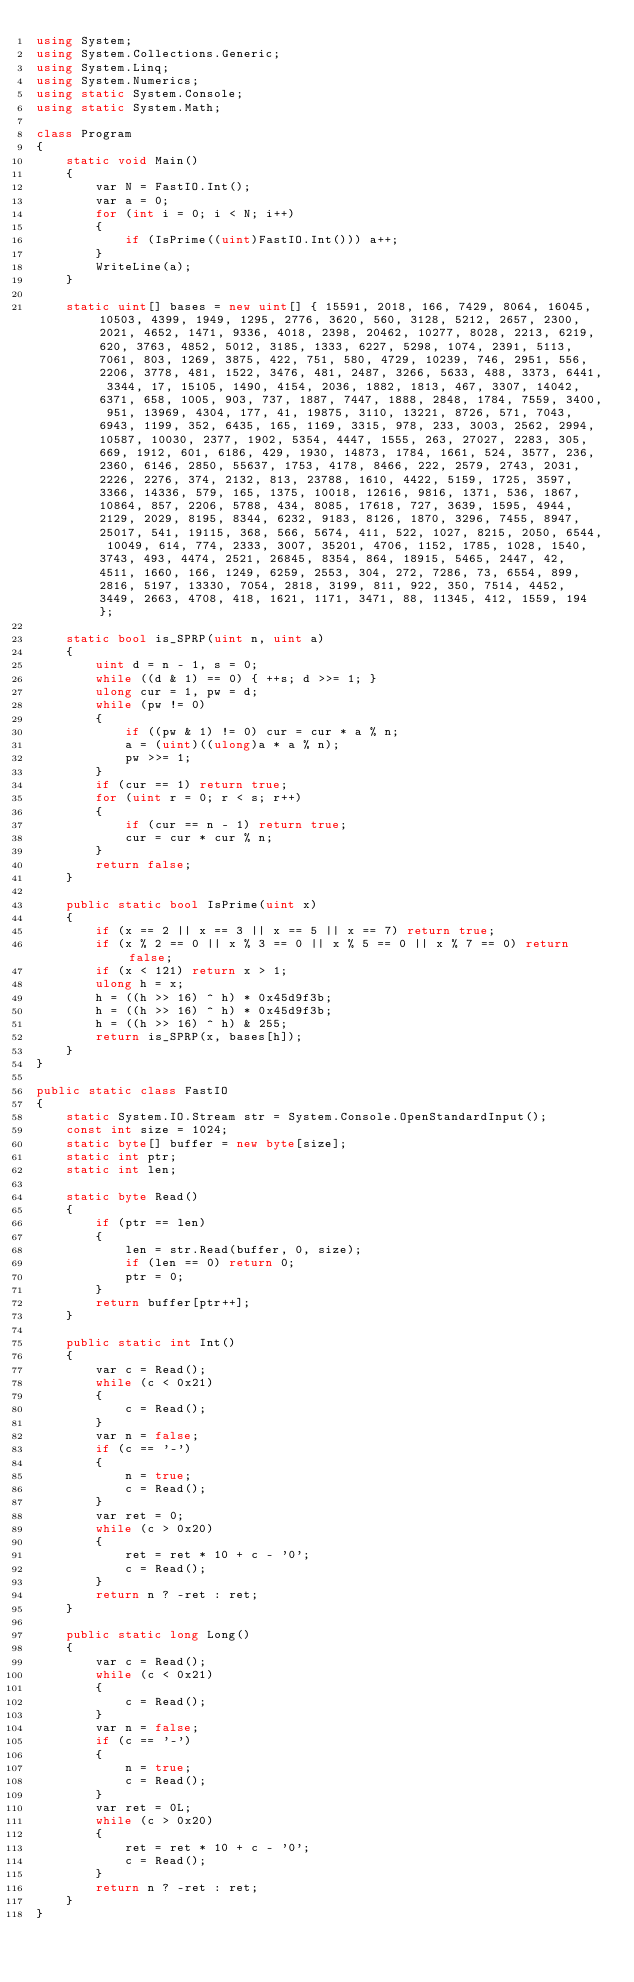<code> <loc_0><loc_0><loc_500><loc_500><_C#_>using System;
using System.Collections.Generic;
using System.Linq;
using System.Numerics;
using static System.Console;
using static System.Math;

class Program
{
    static void Main()
    {
        var N = FastIO.Int();
        var a = 0;
        for (int i = 0; i < N; i++)
        {
            if (IsPrime((uint)FastIO.Int())) a++;
        }
        WriteLine(a);
    }
    
    static uint[] bases = new uint[] { 15591, 2018, 166, 7429, 8064, 16045, 10503, 4399, 1949, 1295, 2776, 3620, 560, 3128, 5212, 2657, 2300, 2021, 4652, 1471, 9336, 4018, 2398, 20462, 10277, 8028, 2213, 6219, 620, 3763, 4852, 5012, 3185, 1333, 6227, 5298, 1074, 2391, 5113, 7061, 803, 1269, 3875, 422, 751, 580, 4729, 10239, 746, 2951, 556, 2206, 3778, 481, 1522, 3476, 481, 2487, 3266, 5633, 488, 3373, 6441, 3344, 17, 15105, 1490, 4154, 2036, 1882, 1813, 467, 3307, 14042, 6371, 658, 1005, 903, 737, 1887, 7447, 1888, 2848, 1784, 7559, 3400, 951, 13969, 4304, 177, 41, 19875, 3110, 13221, 8726, 571, 7043, 6943, 1199, 352, 6435, 165, 1169, 3315, 978, 233, 3003, 2562, 2994, 10587, 10030, 2377, 1902, 5354, 4447, 1555, 263, 27027, 2283, 305, 669, 1912, 601, 6186, 429, 1930, 14873, 1784, 1661, 524, 3577, 236, 2360, 6146, 2850, 55637, 1753, 4178, 8466, 222, 2579, 2743, 2031, 2226, 2276, 374, 2132, 813, 23788, 1610, 4422, 5159, 1725, 3597, 3366, 14336, 579, 165, 1375, 10018, 12616, 9816, 1371, 536, 1867, 10864, 857, 2206, 5788, 434, 8085, 17618, 727, 3639, 1595, 4944, 2129, 2029, 8195, 8344, 6232, 9183, 8126, 1870, 3296, 7455, 8947, 25017, 541, 19115, 368, 566, 5674, 411, 522, 1027, 8215, 2050, 6544, 10049, 614, 774, 2333, 3007, 35201, 4706, 1152, 1785, 1028, 1540, 3743, 493, 4474, 2521, 26845, 8354, 864, 18915, 5465, 2447, 42, 4511, 1660, 166, 1249, 6259, 2553, 304, 272, 7286, 73, 6554, 899, 2816, 5197, 13330, 7054, 2818, 3199, 811, 922, 350, 7514, 4452, 3449, 2663, 4708, 418, 1621, 1171, 3471, 88, 11345, 412, 1559, 194 };

    static bool is_SPRP(uint n, uint a)
    {
        uint d = n - 1, s = 0;
        while ((d & 1) == 0) { ++s; d >>= 1; }
        ulong cur = 1, pw = d;
        while (pw != 0)
        {
            if ((pw & 1) != 0) cur = cur * a % n;
            a = (uint)((ulong)a * a % n);
            pw >>= 1;
        }
        if (cur == 1) return true;
        for (uint r = 0; r < s; r++)
        {
            if (cur == n - 1) return true;
            cur = cur * cur % n;
        }
        return false;
    }

    public static bool IsPrime(uint x)
    {
        if (x == 2 || x == 3 || x == 5 || x == 7) return true;
        if (x % 2 == 0 || x % 3 == 0 || x % 5 == 0 || x % 7 == 0) return false;
        if (x < 121) return x > 1;
        ulong h = x;
        h = ((h >> 16) ^ h) * 0x45d9f3b;
        h = ((h >> 16) ^ h) * 0x45d9f3b;
        h = ((h >> 16) ^ h) & 255;
        return is_SPRP(x, bases[h]);
    }
}

public static class FastIO
{
    static System.IO.Stream str = System.Console.OpenStandardInput();
    const int size = 1024;
    static byte[] buffer = new byte[size];
    static int ptr;
    static int len;

    static byte Read()
    {
        if (ptr == len)
        {
            len = str.Read(buffer, 0, size);
            if (len == 0) return 0;
            ptr = 0;
        }
        return buffer[ptr++];
    }

    public static int Int()
    {
        var c = Read();
        while (c < 0x21)
        {
            c = Read();
        }
        var n = false;
        if (c == '-')
        {
            n = true;
            c = Read();
        }
        var ret = 0;
        while (c > 0x20)
        {
            ret = ret * 10 + c - '0';
            c = Read();
        }
        return n ? -ret : ret;
    }

    public static long Long()
    {
        var c = Read();
        while (c < 0x21)
        {
            c = Read();
        }
        var n = false;
        if (c == '-')
        {
            n = true;
            c = Read();
        }
        var ret = 0L;
        while (c > 0x20)
        {
            ret = ret * 10 + c - '0';
            c = Read();
        }
        return n ? -ret : ret;
    }
}

</code> 